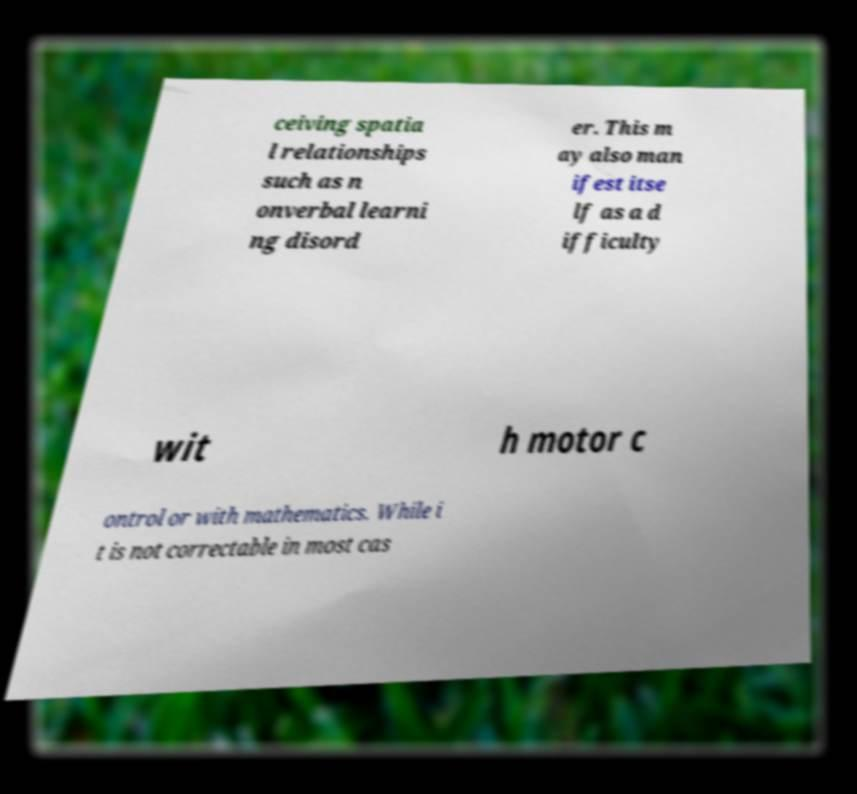Please identify and transcribe the text found in this image. ceiving spatia l relationships such as n onverbal learni ng disord er. This m ay also man ifest itse lf as a d ifficulty wit h motor c ontrol or with mathematics. While i t is not correctable in most cas 